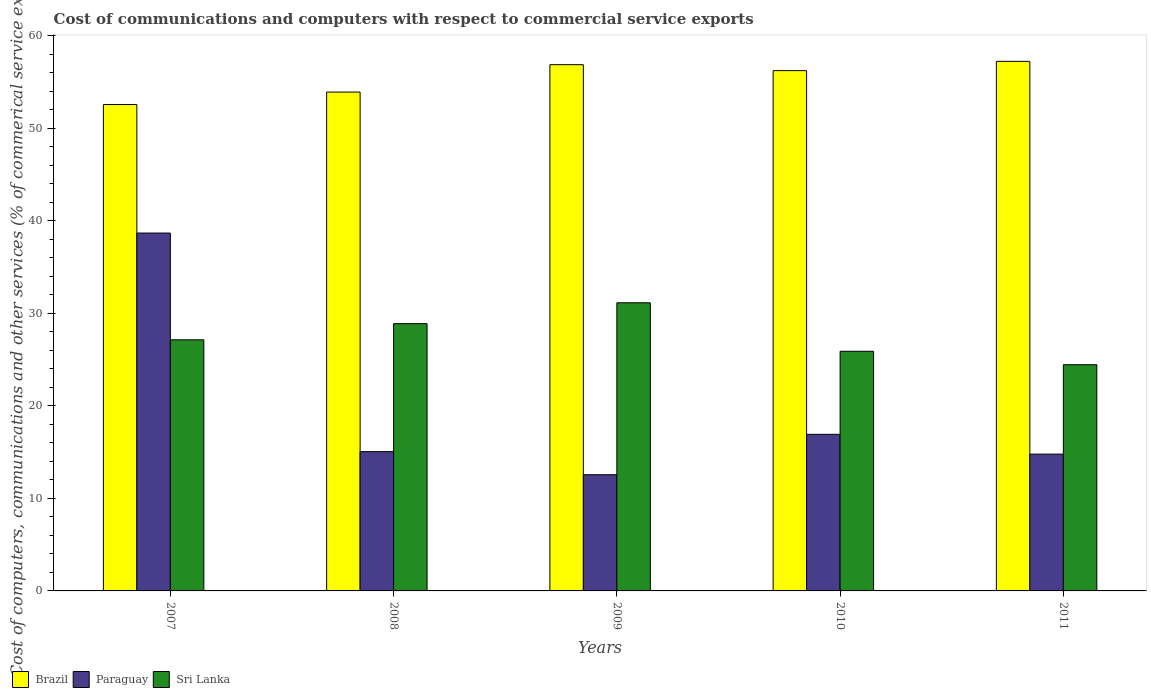How many groups of bars are there?
Make the answer very short. 5. Are the number of bars per tick equal to the number of legend labels?
Ensure brevity in your answer.  Yes. Are the number of bars on each tick of the X-axis equal?
Keep it short and to the point. Yes. How many bars are there on the 1st tick from the right?
Ensure brevity in your answer.  3. What is the cost of communications and computers in Paraguay in 2008?
Offer a terse response. 15.06. Across all years, what is the maximum cost of communications and computers in Brazil?
Your answer should be compact. 57.26. Across all years, what is the minimum cost of communications and computers in Brazil?
Your response must be concise. 52.59. In which year was the cost of communications and computers in Sri Lanka maximum?
Ensure brevity in your answer.  2009. In which year was the cost of communications and computers in Brazil minimum?
Provide a succinct answer. 2007. What is the total cost of communications and computers in Paraguay in the graph?
Make the answer very short. 98.04. What is the difference between the cost of communications and computers in Sri Lanka in 2009 and that in 2011?
Keep it short and to the point. 6.7. What is the difference between the cost of communications and computers in Sri Lanka in 2007 and the cost of communications and computers in Brazil in 2010?
Provide a succinct answer. -29.1. What is the average cost of communications and computers in Brazil per year?
Offer a very short reply. 55.39. In the year 2010, what is the difference between the cost of communications and computers in Sri Lanka and cost of communications and computers in Paraguay?
Your response must be concise. 8.98. In how many years, is the cost of communications and computers in Sri Lanka greater than 8 %?
Your response must be concise. 5. What is the ratio of the cost of communications and computers in Sri Lanka in 2009 to that in 2010?
Give a very brief answer. 1.2. Is the difference between the cost of communications and computers in Sri Lanka in 2007 and 2011 greater than the difference between the cost of communications and computers in Paraguay in 2007 and 2011?
Your response must be concise. No. What is the difference between the highest and the second highest cost of communications and computers in Paraguay?
Ensure brevity in your answer.  21.76. What is the difference between the highest and the lowest cost of communications and computers in Paraguay?
Keep it short and to the point. 26.13. In how many years, is the cost of communications and computers in Paraguay greater than the average cost of communications and computers in Paraguay taken over all years?
Your response must be concise. 1. Is the sum of the cost of communications and computers in Paraguay in 2008 and 2011 greater than the maximum cost of communications and computers in Brazil across all years?
Your answer should be compact. No. What does the 3rd bar from the left in 2008 represents?
Offer a terse response. Sri Lanka. What does the 1st bar from the right in 2007 represents?
Your response must be concise. Sri Lanka. Are all the bars in the graph horizontal?
Offer a very short reply. No. How many years are there in the graph?
Give a very brief answer. 5. What is the difference between two consecutive major ticks on the Y-axis?
Make the answer very short. 10. How many legend labels are there?
Give a very brief answer. 3. What is the title of the graph?
Offer a very short reply. Cost of communications and computers with respect to commercial service exports. What is the label or title of the X-axis?
Provide a succinct answer. Years. What is the label or title of the Y-axis?
Offer a very short reply. Cost of computers, communications and other services (% of commerical service exports). What is the Cost of computers, communications and other services (% of commerical service exports) in Brazil in 2007?
Make the answer very short. 52.59. What is the Cost of computers, communications and other services (% of commerical service exports) in Paraguay in 2007?
Ensure brevity in your answer.  38.69. What is the Cost of computers, communications and other services (% of commerical service exports) in Sri Lanka in 2007?
Make the answer very short. 27.15. What is the Cost of computers, communications and other services (% of commerical service exports) in Brazil in 2008?
Give a very brief answer. 53.94. What is the Cost of computers, communications and other services (% of commerical service exports) in Paraguay in 2008?
Ensure brevity in your answer.  15.06. What is the Cost of computers, communications and other services (% of commerical service exports) in Sri Lanka in 2008?
Offer a very short reply. 28.9. What is the Cost of computers, communications and other services (% of commerical service exports) in Brazil in 2009?
Keep it short and to the point. 56.9. What is the Cost of computers, communications and other services (% of commerical service exports) of Paraguay in 2009?
Provide a short and direct response. 12.56. What is the Cost of computers, communications and other services (% of commerical service exports) of Sri Lanka in 2009?
Your response must be concise. 31.16. What is the Cost of computers, communications and other services (% of commerical service exports) in Brazil in 2010?
Make the answer very short. 56.25. What is the Cost of computers, communications and other services (% of commerical service exports) of Paraguay in 2010?
Offer a very short reply. 16.93. What is the Cost of computers, communications and other services (% of commerical service exports) in Sri Lanka in 2010?
Provide a succinct answer. 25.91. What is the Cost of computers, communications and other services (% of commerical service exports) of Brazil in 2011?
Keep it short and to the point. 57.26. What is the Cost of computers, communications and other services (% of commerical service exports) in Paraguay in 2011?
Make the answer very short. 14.79. What is the Cost of computers, communications and other services (% of commerical service exports) of Sri Lanka in 2011?
Provide a short and direct response. 24.46. Across all years, what is the maximum Cost of computers, communications and other services (% of commerical service exports) in Brazil?
Ensure brevity in your answer.  57.26. Across all years, what is the maximum Cost of computers, communications and other services (% of commerical service exports) in Paraguay?
Offer a terse response. 38.69. Across all years, what is the maximum Cost of computers, communications and other services (% of commerical service exports) in Sri Lanka?
Give a very brief answer. 31.16. Across all years, what is the minimum Cost of computers, communications and other services (% of commerical service exports) in Brazil?
Your response must be concise. 52.59. Across all years, what is the minimum Cost of computers, communications and other services (% of commerical service exports) in Paraguay?
Give a very brief answer. 12.56. Across all years, what is the minimum Cost of computers, communications and other services (% of commerical service exports) of Sri Lanka?
Provide a succinct answer. 24.46. What is the total Cost of computers, communications and other services (% of commerical service exports) of Brazil in the graph?
Ensure brevity in your answer.  276.94. What is the total Cost of computers, communications and other services (% of commerical service exports) of Paraguay in the graph?
Ensure brevity in your answer.  98.04. What is the total Cost of computers, communications and other services (% of commerical service exports) of Sri Lanka in the graph?
Give a very brief answer. 137.57. What is the difference between the Cost of computers, communications and other services (% of commerical service exports) of Brazil in 2007 and that in 2008?
Ensure brevity in your answer.  -1.35. What is the difference between the Cost of computers, communications and other services (% of commerical service exports) of Paraguay in 2007 and that in 2008?
Your answer should be very brief. 23.63. What is the difference between the Cost of computers, communications and other services (% of commerical service exports) of Sri Lanka in 2007 and that in 2008?
Your response must be concise. -1.75. What is the difference between the Cost of computers, communications and other services (% of commerical service exports) in Brazil in 2007 and that in 2009?
Your answer should be compact. -4.31. What is the difference between the Cost of computers, communications and other services (% of commerical service exports) in Paraguay in 2007 and that in 2009?
Your response must be concise. 26.13. What is the difference between the Cost of computers, communications and other services (% of commerical service exports) of Sri Lanka in 2007 and that in 2009?
Your response must be concise. -4.01. What is the difference between the Cost of computers, communications and other services (% of commerical service exports) of Brazil in 2007 and that in 2010?
Keep it short and to the point. -3.67. What is the difference between the Cost of computers, communications and other services (% of commerical service exports) of Paraguay in 2007 and that in 2010?
Make the answer very short. 21.76. What is the difference between the Cost of computers, communications and other services (% of commerical service exports) of Sri Lanka in 2007 and that in 2010?
Provide a succinct answer. 1.24. What is the difference between the Cost of computers, communications and other services (% of commerical service exports) of Brazil in 2007 and that in 2011?
Provide a succinct answer. -4.67. What is the difference between the Cost of computers, communications and other services (% of commerical service exports) of Paraguay in 2007 and that in 2011?
Make the answer very short. 23.9. What is the difference between the Cost of computers, communications and other services (% of commerical service exports) of Sri Lanka in 2007 and that in 2011?
Your response must be concise. 2.69. What is the difference between the Cost of computers, communications and other services (% of commerical service exports) in Brazil in 2008 and that in 2009?
Your answer should be compact. -2.96. What is the difference between the Cost of computers, communications and other services (% of commerical service exports) of Paraguay in 2008 and that in 2009?
Your response must be concise. 2.5. What is the difference between the Cost of computers, communications and other services (% of commerical service exports) in Sri Lanka in 2008 and that in 2009?
Offer a very short reply. -2.26. What is the difference between the Cost of computers, communications and other services (% of commerical service exports) in Brazil in 2008 and that in 2010?
Your answer should be compact. -2.32. What is the difference between the Cost of computers, communications and other services (% of commerical service exports) in Paraguay in 2008 and that in 2010?
Your response must be concise. -1.87. What is the difference between the Cost of computers, communications and other services (% of commerical service exports) of Sri Lanka in 2008 and that in 2010?
Give a very brief answer. 2.99. What is the difference between the Cost of computers, communications and other services (% of commerical service exports) of Brazil in 2008 and that in 2011?
Your answer should be very brief. -3.32. What is the difference between the Cost of computers, communications and other services (% of commerical service exports) of Paraguay in 2008 and that in 2011?
Keep it short and to the point. 0.27. What is the difference between the Cost of computers, communications and other services (% of commerical service exports) in Sri Lanka in 2008 and that in 2011?
Offer a terse response. 4.44. What is the difference between the Cost of computers, communications and other services (% of commerical service exports) in Brazil in 2009 and that in 2010?
Ensure brevity in your answer.  0.64. What is the difference between the Cost of computers, communications and other services (% of commerical service exports) of Paraguay in 2009 and that in 2010?
Provide a short and direct response. -4.37. What is the difference between the Cost of computers, communications and other services (% of commerical service exports) of Sri Lanka in 2009 and that in 2010?
Offer a terse response. 5.25. What is the difference between the Cost of computers, communications and other services (% of commerical service exports) in Brazil in 2009 and that in 2011?
Your response must be concise. -0.36. What is the difference between the Cost of computers, communications and other services (% of commerical service exports) in Paraguay in 2009 and that in 2011?
Offer a very short reply. -2.23. What is the difference between the Cost of computers, communications and other services (% of commerical service exports) of Sri Lanka in 2009 and that in 2011?
Offer a very short reply. 6.7. What is the difference between the Cost of computers, communications and other services (% of commerical service exports) in Brazil in 2010 and that in 2011?
Keep it short and to the point. -1. What is the difference between the Cost of computers, communications and other services (% of commerical service exports) in Paraguay in 2010 and that in 2011?
Give a very brief answer. 2.14. What is the difference between the Cost of computers, communications and other services (% of commerical service exports) in Sri Lanka in 2010 and that in 2011?
Offer a very short reply. 1.45. What is the difference between the Cost of computers, communications and other services (% of commerical service exports) in Brazil in 2007 and the Cost of computers, communications and other services (% of commerical service exports) in Paraguay in 2008?
Your response must be concise. 37.53. What is the difference between the Cost of computers, communications and other services (% of commerical service exports) of Brazil in 2007 and the Cost of computers, communications and other services (% of commerical service exports) of Sri Lanka in 2008?
Your response must be concise. 23.69. What is the difference between the Cost of computers, communications and other services (% of commerical service exports) in Paraguay in 2007 and the Cost of computers, communications and other services (% of commerical service exports) in Sri Lanka in 2008?
Offer a very short reply. 9.8. What is the difference between the Cost of computers, communications and other services (% of commerical service exports) in Brazil in 2007 and the Cost of computers, communications and other services (% of commerical service exports) in Paraguay in 2009?
Keep it short and to the point. 40.02. What is the difference between the Cost of computers, communications and other services (% of commerical service exports) in Brazil in 2007 and the Cost of computers, communications and other services (% of commerical service exports) in Sri Lanka in 2009?
Provide a succinct answer. 21.43. What is the difference between the Cost of computers, communications and other services (% of commerical service exports) in Paraguay in 2007 and the Cost of computers, communications and other services (% of commerical service exports) in Sri Lanka in 2009?
Offer a very short reply. 7.54. What is the difference between the Cost of computers, communications and other services (% of commerical service exports) in Brazil in 2007 and the Cost of computers, communications and other services (% of commerical service exports) in Paraguay in 2010?
Offer a terse response. 35.66. What is the difference between the Cost of computers, communications and other services (% of commerical service exports) of Brazil in 2007 and the Cost of computers, communications and other services (% of commerical service exports) of Sri Lanka in 2010?
Give a very brief answer. 26.68. What is the difference between the Cost of computers, communications and other services (% of commerical service exports) of Paraguay in 2007 and the Cost of computers, communications and other services (% of commerical service exports) of Sri Lanka in 2010?
Your answer should be very brief. 12.79. What is the difference between the Cost of computers, communications and other services (% of commerical service exports) in Brazil in 2007 and the Cost of computers, communications and other services (% of commerical service exports) in Paraguay in 2011?
Make the answer very short. 37.8. What is the difference between the Cost of computers, communications and other services (% of commerical service exports) in Brazil in 2007 and the Cost of computers, communications and other services (% of commerical service exports) in Sri Lanka in 2011?
Your response must be concise. 28.13. What is the difference between the Cost of computers, communications and other services (% of commerical service exports) of Paraguay in 2007 and the Cost of computers, communications and other services (% of commerical service exports) of Sri Lanka in 2011?
Your answer should be very brief. 14.24. What is the difference between the Cost of computers, communications and other services (% of commerical service exports) of Brazil in 2008 and the Cost of computers, communications and other services (% of commerical service exports) of Paraguay in 2009?
Make the answer very short. 41.37. What is the difference between the Cost of computers, communications and other services (% of commerical service exports) of Brazil in 2008 and the Cost of computers, communications and other services (% of commerical service exports) of Sri Lanka in 2009?
Your answer should be compact. 22.78. What is the difference between the Cost of computers, communications and other services (% of commerical service exports) of Paraguay in 2008 and the Cost of computers, communications and other services (% of commerical service exports) of Sri Lanka in 2009?
Give a very brief answer. -16.09. What is the difference between the Cost of computers, communications and other services (% of commerical service exports) in Brazil in 2008 and the Cost of computers, communications and other services (% of commerical service exports) in Paraguay in 2010?
Keep it short and to the point. 37.01. What is the difference between the Cost of computers, communications and other services (% of commerical service exports) in Brazil in 2008 and the Cost of computers, communications and other services (% of commerical service exports) in Sri Lanka in 2010?
Your answer should be very brief. 28.03. What is the difference between the Cost of computers, communications and other services (% of commerical service exports) of Paraguay in 2008 and the Cost of computers, communications and other services (% of commerical service exports) of Sri Lanka in 2010?
Provide a short and direct response. -10.85. What is the difference between the Cost of computers, communications and other services (% of commerical service exports) of Brazil in 2008 and the Cost of computers, communications and other services (% of commerical service exports) of Paraguay in 2011?
Give a very brief answer. 39.15. What is the difference between the Cost of computers, communications and other services (% of commerical service exports) in Brazil in 2008 and the Cost of computers, communications and other services (% of commerical service exports) in Sri Lanka in 2011?
Provide a succinct answer. 29.48. What is the difference between the Cost of computers, communications and other services (% of commerical service exports) of Paraguay in 2008 and the Cost of computers, communications and other services (% of commerical service exports) of Sri Lanka in 2011?
Provide a short and direct response. -9.4. What is the difference between the Cost of computers, communications and other services (% of commerical service exports) in Brazil in 2009 and the Cost of computers, communications and other services (% of commerical service exports) in Paraguay in 2010?
Make the answer very short. 39.97. What is the difference between the Cost of computers, communications and other services (% of commerical service exports) of Brazil in 2009 and the Cost of computers, communications and other services (% of commerical service exports) of Sri Lanka in 2010?
Your answer should be very brief. 30.99. What is the difference between the Cost of computers, communications and other services (% of commerical service exports) in Paraguay in 2009 and the Cost of computers, communications and other services (% of commerical service exports) in Sri Lanka in 2010?
Your answer should be very brief. -13.34. What is the difference between the Cost of computers, communications and other services (% of commerical service exports) in Brazil in 2009 and the Cost of computers, communications and other services (% of commerical service exports) in Paraguay in 2011?
Make the answer very short. 42.11. What is the difference between the Cost of computers, communications and other services (% of commerical service exports) in Brazil in 2009 and the Cost of computers, communications and other services (% of commerical service exports) in Sri Lanka in 2011?
Offer a terse response. 32.44. What is the difference between the Cost of computers, communications and other services (% of commerical service exports) of Paraguay in 2009 and the Cost of computers, communications and other services (% of commerical service exports) of Sri Lanka in 2011?
Provide a succinct answer. -11.89. What is the difference between the Cost of computers, communications and other services (% of commerical service exports) of Brazil in 2010 and the Cost of computers, communications and other services (% of commerical service exports) of Paraguay in 2011?
Provide a succinct answer. 41.46. What is the difference between the Cost of computers, communications and other services (% of commerical service exports) of Brazil in 2010 and the Cost of computers, communications and other services (% of commerical service exports) of Sri Lanka in 2011?
Your answer should be very brief. 31.8. What is the difference between the Cost of computers, communications and other services (% of commerical service exports) of Paraguay in 2010 and the Cost of computers, communications and other services (% of commerical service exports) of Sri Lanka in 2011?
Make the answer very short. -7.53. What is the average Cost of computers, communications and other services (% of commerical service exports) of Brazil per year?
Give a very brief answer. 55.39. What is the average Cost of computers, communications and other services (% of commerical service exports) of Paraguay per year?
Ensure brevity in your answer.  19.61. What is the average Cost of computers, communications and other services (% of commerical service exports) in Sri Lanka per year?
Provide a succinct answer. 27.51. In the year 2007, what is the difference between the Cost of computers, communications and other services (% of commerical service exports) of Brazil and Cost of computers, communications and other services (% of commerical service exports) of Paraguay?
Ensure brevity in your answer.  13.89. In the year 2007, what is the difference between the Cost of computers, communications and other services (% of commerical service exports) in Brazil and Cost of computers, communications and other services (% of commerical service exports) in Sri Lanka?
Your answer should be compact. 25.44. In the year 2007, what is the difference between the Cost of computers, communications and other services (% of commerical service exports) in Paraguay and Cost of computers, communications and other services (% of commerical service exports) in Sri Lanka?
Keep it short and to the point. 11.54. In the year 2008, what is the difference between the Cost of computers, communications and other services (% of commerical service exports) of Brazil and Cost of computers, communications and other services (% of commerical service exports) of Paraguay?
Provide a succinct answer. 38.88. In the year 2008, what is the difference between the Cost of computers, communications and other services (% of commerical service exports) of Brazil and Cost of computers, communications and other services (% of commerical service exports) of Sri Lanka?
Offer a terse response. 25.04. In the year 2008, what is the difference between the Cost of computers, communications and other services (% of commerical service exports) in Paraguay and Cost of computers, communications and other services (% of commerical service exports) in Sri Lanka?
Offer a terse response. -13.84. In the year 2009, what is the difference between the Cost of computers, communications and other services (% of commerical service exports) of Brazil and Cost of computers, communications and other services (% of commerical service exports) of Paraguay?
Your answer should be very brief. 44.33. In the year 2009, what is the difference between the Cost of computers, communications and other services (% of commerical service exports) in Brazil and Cost of computers, communications and other services (% of commerical service exports) in Sri Lanka?
Your answer should be very brief. 25.74. In the year 2009, what is the difference between the Cost of computers, communications and other services (% of commerical service exports) in Paraguay and Cost of computers, communications and other services (% of commerical service exports) in Sri Lanka?
Your answer should be very brief. -18.59. In the year 2010, what is the difference between the Cost of computers, communications and other services (% of commerical service exports) of Brazil and Cost of computers, communications and other services (% of commerical service exports) of Paraguay?
Your response must be concise. 39.32. In the year 2010, what is the difference between the Cost of computers, communications and other services (% of commerical service exports) in Brazil and Cost of computers, communications and other services (% of commerical service exports) in Sri Lanka?
Provide a succinct answer. 30.35. In the year 2010, what is the difference between the Cost of computers, communications and other services (% of commerical service exports) of Paraguay and Cost of computers, communications and other services (% of commerical service exports) of Sri Lanka?
Offer a very short reply. -8.98. In the year 2011, what is the difference between the Cost of computers, communications and other services (% of commerical service exports) in Brazil and Cost of computers, communications and other services (% of commerical service exports) in Paraguay?
Provide a succinct answer. 42.47. In the year 2011, what is the difference between the Cost of computers, communications and other services (% of commerical service exports) in Brazil and Cost of computers, communications and other services (% of commerical service exports) in Sri Lanka?
Provide a short and direct response. 32.8. In the year 2011, what is the difference between the Cost of computers, communications and other services (% of commerical service exports) in Paraguay and Cost of computers, communications and other services (% of commerical service exports) in Sri Lanka?
Ensure brevity in your answer.  -9.67. What is the ratio of the Cost of computers, communications and other services (% of commerical service exports) in Brazil in 2007 to that in 2008?
Keep it short and to the point. 0.97. What is the ratio of the Cost of computers, communications and other services (% of commerical service exports) in Paraguay in 2007 to that in 2008?
Ensure brevity in your answer.  2.57. What is the ratio of the Cost of computers, communications and other services (% of commerical service exports) in Sri Lanka in 2007 to that in 2008?
Offer a very short reply. 0.94. What is the ratio of the Cost of computers, communications and other services (% of commerical service exports) in Brazil in 2007 to that in 2009?
Make the answer very short. 0.92. What is the ratio of the Cost of computers, communications and other services (% of commerical service exports) in Paraguay in 2007 to that in 2009?
Keep it short and to the point. 3.08. What is the ratio of the Cost of computers, communications and other services (% of commerical service exports) in Sri Lanka in 2007 to that in 2009?
Offer a terse response. 0.87. What is the ratio of the Cost of computers, communications and other services (% of commerical service exports) of Brazil in 2007 to that in 2010?
Give a very brief answer. 0.93. What is the ratio of the Cost of computers, communications and other services (% of commerical service exports) of Paraguay in 2007 to that in 2010?
Your answer should be compact. 2.29. What is the ratio of the Cost of computers, communications and other services (% of commerical service exports) in Sri Lanka in 2007 to that in 2010?
Your answer should be compact. 1.05. What is the ratio of the Cost of computers, communications and other services (% of commerical service exports) in Brazil in 2007 to that in 2011?
Your answer should be very brief. 0.92. What is the ratio of the Cost of computers, communications and other services (% of commerical service exports) in Paraguay in 2007 to that in 2011?
Your response must be concise. 2.62. What is the ratio of the Cost of computers, communications and other services (% of commerical service exports) of Sri Lanka in 2007 to that in 2011?
Keep it short and to the point. 1.11. What is the ratio of the Cost of computers, communications and other services (% of commerical service exports) of Brazil in 2008 to that in 2009?
Your answer should be very brief. 0.95. What is the ratio of the Cost of computers, communications and other services (% of commerical service exports) of Paraguay in 2008 to that in 2009?
Ensure brevity in your answer.  1.2. What is the ratio of the Cost of computers, communications and other services (% of commerical service exports) of Sri Lanka in 2008 to that in 2009?
Make the answer very short. 0.93. What is the ratio of the Cost of computers, communications and other services (% of commerical service exports) of Brazil in 2008 to that in 2010?
Offer a very short reply. 0.96. What is the ratio of the Cost of computers, communications and other services (% of commerical service exports) of Paraguay in 2008 to that in 2010?
Your answer should be compact. 0.89. What is the ratio of the Cost of computers, communications and other services (% of commerical service exports) of Sri Lanka in 2008 to that in 2010?
Offer a very short reply. 1.12. What is the ratio of the Cost of computers, communications and other services (% of commerical service exports) of Brazil in 2008 to that in 2011?
Your answer should be very brief. 0.94. What is the ratio of the Cost of computers, communications and other services (% of commerical service exports) of Paraguay in 2008 to that in 2011?
Ensure brevity in your answer.  1.02. What is the ratio of the Cost of computers, communications and other services (% of commerical service exports) in Sri Lanka in 2008 to that in 2011?
Provide a short and direct response. 1.18. What is the ratio of the Cost of computers, communications and other services (% of commerical service exports) of Brazil in 2009 to that in 2010?
Give a very brief answer. 1.01. What is the ratio of the Cost of computers, communications and other services (% of commerical service exports) in Paraguay in 2009 to that in 2010?
Give a very brief answer. 0.74. What is the ratio of the Cost of computers, communications and other services (% of commerical service exports) of Sri Lanka in 2009 to that in 2010?
Provide a short and direct response. 1.2. What is the ratio of the Cost of computers, communications and other services (% of commerical service exports) in Brazil in 2009 to that in 2011?
Offer a very short reply. 0.99. What is the ratio of the Cost of computers, communications and other services (% of commerical service exports) in Paraguay in 2009 to that in 2011?
Ensure brevity in your answer.  0.85. What is the ratio of the Cost of computers, communications and other services (% of commerical service exports) in Sri Lanka in 2009 to that in 2011?
Offer a very short reply. 1.27. What is the ratio of the Cost of computers, communications and other services (% of commerical service exports) in Brazil in 2010 to that in 2011?
Give a very brief answer. 0.98. What is the ratio of the Cost of computers, communications and other services (% of commerical service exports) of Paraguay in 2010 to that in 2011?
Make the answer very short. 1.14. What is the ratio of the Cost of computers, communications and other services (% of commerical service exports) of Sri Lanka in 2010 to that in 2011?
Offer a very short reply. 1.06. What is the difference between the highest and the second highest Cost of computers, communications and other services (% of commerical service exports) of Brazil?
Offer a very short reply. 0.36. What is the difference between the highest and the second highest Cost of computers, communications and other services (% of commerical service exports) of Paraguay?
Offer a very short reply. 21.76. What is the difference between the highest and the second highest Cost of computers, communications and other services (% of commerical service exports) of Sri Lanka?
Ensure brevity in your answer.  2.26. What is the difference between the highest and the lowest Cost of computers, communications and other services (% of commerical service exports) of Brazil?
Ensure brevity in your answer.  4.67. What is the difference between the highest and the lowest Cost of computers, communications and other services (% of commerical service exports) of Paraguay?
Give a very brief answer. 26.13. What is the difference between the highest and the lowest Cost of computers, communications and other services (% of commerical service exports) in Sri Lanka?
Ensure brevity in your answer.  6.7. 